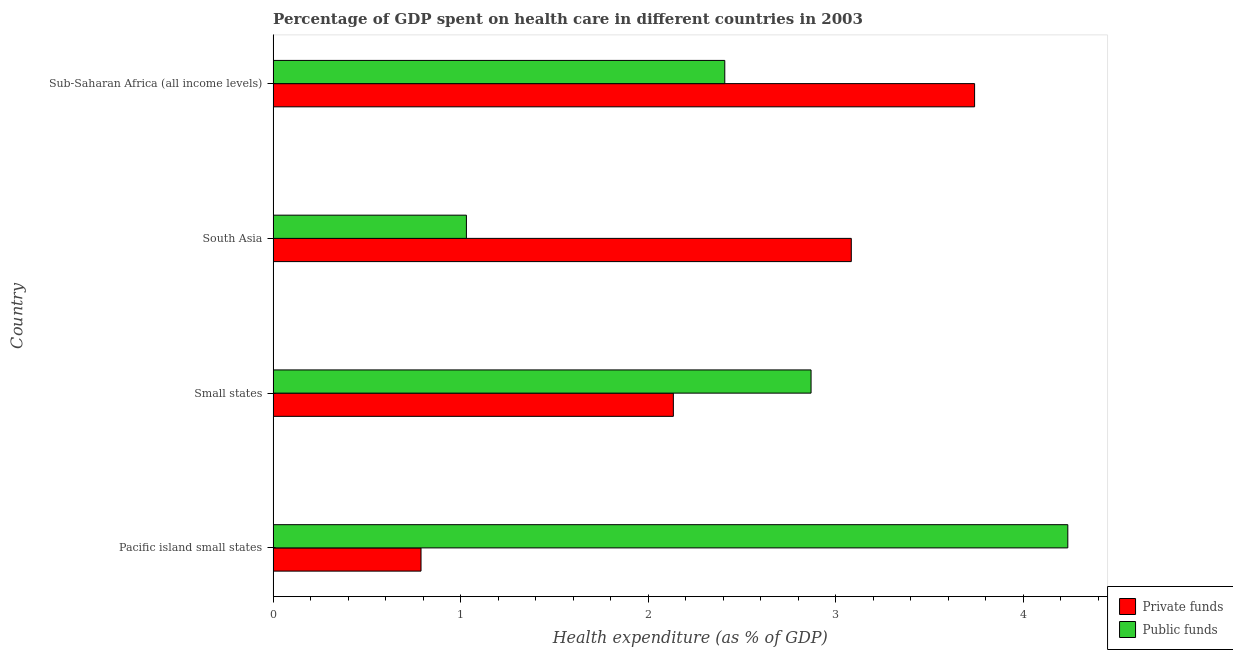How many groups of bars are there?
Offer a very short reply. 4. How many bars are there on the 3rd tick from the top?
Your response must be concise. 2. What is the label of the 1st group of bars from the top?
Your answer should be very brief. Sub-Saharan Africa (all income levels). What is the amount of private funds spent in healthcare in Pacific island small states?
Offer a terse response. 0.79. Across all countries, what is the maximum amount of public funds spent in healthcare?
Your response must be concise. 4.24. Across all countries, what is the minimum amount of private funds spent in healthcare?
Your answer should be very brief. 0.79. In which country was the amount of private funds spent in healthcare maximum?
Provide a succinct answer. Sub-Saharan Africa (all income levels). In which country was the amount of private funds spent in healthcare minimum?
Provide a succinct answer. Pacific island small states. What is the total amount of public funds spent in healthcare in the graph?
Offer a terse response. 10.54. What is the difference between the amount of public funds spent in healthcare in South Asia and that in Sub-Saharan Africa (all income levels)?
Give a very brief answer. -1.38. What is the difference between the amount of public funds spent in healthcare in Pacific island small states and the amount of private funds spent in healthcare in Sub-Saharan Africa (all income levels)?
Offer a terse response. 0.5. What is the average amount of public funds spent in healthcare per country?
Provide a succinct answer. 2.64. What is the difference between the amount of public funds spent in healthcare and amount of private funds spent in healthcare in South Asia?
Provide a short and direct response. -2.05. In how many countries, is the amount of public funds spent in healthcare greater than 2.6 %?
Provide a short and direct response. 2. What is the ratio of the amount of public funds spent in healthcare in Small states to that in South Asia?
Your response must be concise. 2.78. What is the difference between the highest and the second highest amount of private funds spent in healthcare?
Offer a very short reply. 0.66. What is the difference between the highest and the lowest amount of public funds spent in healthcare?
Your response must be concise. 3.21. In how many countries, is the amount of private funds spent in healthcare greater than the average amount of private funds spent in healthcare taken over all countries?
Your answer should be very brief. 2. Is the sum of the amount of private funds spent in healthcare in Pacific island small states and Small states greater than the maximum amount of public funds spent in healthcare across all countries?
Give a very brief answer. No. What does the 1st bar from the top in Small states represents?
Provide a short and direct response. Public funds. What does the 1st bar from the bottom in Sub-Saharan Africa (all income levels) represents?
Make the answer very short. Private funds. How many bars are there?
Ensure brevity in your answer.  8. Are all the bars in the graph horizontal?
Provide a succinct answer. Yes. How many countries are there in the graph?
Keep it short and to the point. 4. What is the difference between two consecutive major ticks on the X-axis?
Your response must be concise. 1. Are the values on the major ticks of X-axis written in scientific E-notation?
Provide a succinct answer. No. Does the graph contain any zero values?
Provide a succinct answer. No. Does the graph contain grids?
Your response must be concise. No. Where does the legend appear in the graph?
Your answer should be very brief. Bottom right. How are the legend labels stacked?
Provide a short and direct response. Vertical. What is the title of the graph?
Your answer should be very brief. Percentage of GDP spent on health care in different countries in 2003. What is the label or title of the X-axis?
Provide a short and direct response. Health expenditure (as % of GDP). What is the label or title of the Y-axis?
Your answer should be compact. Country. What is the Health expenditure (as % of GDP) of Private funds in Pacific island small states?
Ensure brevity in your answer.  0.79. What is the Health expenditure (as % of GDP) of Public funds in Pacific island small states?
Your response must be concise. 4.24. What is the Health expenditure (as % of GDP) in Private funds in Small states?
Your answer should be compact. 2.13. What is the Health expenditure (as % of GDP) in Public funds in Small states?
Offer a very short reply. 2.87. What is the Health expenditure (as % of GDP) of Private funds in South Asia?
Keep it short and to the point. 3.08. What is the Health expenditure (as % of GDP) in Public funds in South Asia?
Offer a very short reply. 1.03. What is the Health expenditure (as % of GDP) of Private funds in Sub-Saharan Africa (all income levels)?
Your response must be concise. 3.74. What is the Health expenditure (as % of GDP) of Public funds in Sub-Saharan Africa (all income levels)?
Offer a terse response. 2.41. Across all countries, what is the maximum Health expenditure (as % of GDP) of Private funds?
Offer a very short reply. 3.74. Across all countries, what is the maximum Health expenditure (as % of GDP) of Public funds?
Offer a terse response. 4.24. Across all countries, what is the minimum Health expenditure (as % of GDP) in Private funds?
Your answer should be compact. 0.79. Across all countries, what is the minimum Health expenditure (as % of GDP) in Public funds?
Give a very brief answer. 1.03. What is the total Health expenditure (as % of GDP) of Private funds in the graph?
Your answer should be very brief. 9.75. What is the total Health expenditure (as % of GDP) in Public funds in the graph?
Your response must be concise. 10.54. What is the difference between the Health expenditure (as % of GDP) of Private funds in Pacific island small states and that in Small states?
Keep it short and to the point. -1.35. What is the difference between the Health expenditure (as % of GDP) in Public funds in Pacific island small states and that in Small states?
Your response must be concise. 1.37. What is the difference between the Health expenditure (as % of GDP) of Private funds in Pacific island small states and that in South Asia?
Your answer should be compact. -2.29. What is the difference between the Health expenditure (as % of GDP) in Public funds in Pacific island small states and that in South Asia?
Make the answer very short. 3.21. What is the difference between the Health expenditure (as % of GDP) in Private funds in Pacific island small states and that in Sub-Saharan Africa (all income levels)?
Provide a succinct answer. -2.95. What is the difference between the Health expenditure (as % of GDP) of Public funds in Pacific island small states and that in Sub-Saharan Africa (all income levels)?
Offer a very short reply. 1.83. What is the difference between the Health expenditure (as % of GDP) in Private funds in Small states and that in South Asia?
Offer a terse response. -0.95. What is the difference between the Health expenditure (as % of GDP) of Public funds in Small states and that in South Asia?
Your answer should be very brief. 1.84. What is the difference between the Health expenditure (as % of GDP) of Private funds in Small states and that in Sub-Saharan Africa (all income levels)?
Give a very brief answer. -1.61. What is the difference between the Health expenditure (as % of GDP) of Public funds in Small states and that in Sub-Saharan Africa (all income levels)?
Offer a terse response. 0.46. What is the difference between the Health expenditure (as % of GDP) in Private funds in South Asia and that in Sub-Saharan Africa (all income levels)?
Make the answer very short. -0.66. What is the difference between the Health expenditure (as % of GDP) of Public funds in South Asia and that in Sub-Saharan Africa (all income levels)?
Keep it short and to the point. -1.38. What is the difference between the Health expenditure (as % of GDP) of Private funds in Pacific island small states and the Health expenditure (as % of GDP) of Public funds in Small states?
Provide a short and direct response. -2.08. What is the difference between the Health expenditure (as % of GDP) in Private funds in Pacific island small states and the Health expenditure (as % of GDP) in Public funds in South Asia?
Your response must be concise. -0.24. What is the difference between the Health expenditure (as % of GDP) in Private funds in Pacific island small states and the Health expenditure (as % of GDP) in Public funds in Sub-Saharan Africa (all income levels)?
Provide a short and direct response. -1.62. What is the difference between the Health expenditure (as % of GDP) of Private funds in Small states and the Health expenditure (as % of GDP) of Public funds in South Asia?
Provide a short and direct response. 1.1. What is the difference between the Health expenditure (as % of GDP) of Private funds in Small states and the Health expenditure (as % of GDP) of Public funds in Sub-Saharan Africa (all income levels)?
Ensure brevity in your answer.  -0.27. What is the difference between the Health expenditure (as % of GDP) in Private funds in South Asia and the Health expenditure (as % of GDP) in Public funds in Sub-Saharan Africa (all income levels)?
Give a very brief answer. 0.67. What is the average Health expenditure (as % of GDP) of Private funds per country?
Your answer should be very brief. 2.44. What is the average Health expenditure (as % of GDP) of Public funds per country?
Ensure brevity in your answer.  2.64. What is the difference between the Health expenditure (as % of GDP) in Private funds and Health expenditure (as % of GDP) in Public funds in Pacific island small states?
Your response must be concise. -3.45. What is the difference between the Health expenditure (as % of GDP) of Private funds and Health expenditure (as % of GDP) of Public funds in Small states?
Your response must be concise. -0.73. What is the difference between the Health expenditure (as % of GDP) in Private funds and Health expenditure (as % of GDP) in Public funds in South Asia?
Provide a short and direct response. 2.05. What is the difference between the Health expenditure (as % of GDP) in Private funds and Health expenditure (as % of GDP) in Public funds in Sub-Saharan Africa (all income levels)?
Provide a succinct answer. 1.33. What is the ratio of the Health expenditure (as % of GDP) of Private funds in Pacific island small states to that in Small states?
Your response must be concise. 0.37. What is the ratio of the Health expenditure (as % of GDP) in Public funds in Pacific island small states to that in Small states?
Provide a succinct answer. 1.48. What is the ratio of the Health expenditure (as % of GDP) of Private funds in Pacific island small states to that in South Asia?
Make the answer very short. 0.26. What is the ratio of the Health expenditure (as % of GDP) of Public funds in Pacific island small states to that in South Asia?
Offer a terse response. 4.11. What is the ratio of the Health expenditure (as % of GDP) of Private funds in Pacific island small states to that in Sub-Saharan Africa (all income levels)?
Keep it short and to the point. 0.21. What is the ratio of the Health expenditure (as % of GDP) in Public funds in Pacific island small states to that in Sub-Saharan Africa (all income levels)?
Provide a succinct answer. 1.76. What is the ratio of the Health expenditure (as % of GDP) of Private funds in Small states to that in South Asia?
Keep it short and to the point. 0.69. What is the ratio of the Health expenditure (as % of GDP) of Public funds in Small states to that in South Asia?
Make the answer very short. 2.78. What is the ratio of the Health expenditure (as % of GDP) in Private funds in Small states to that in Sub-Saharan Africa (all income levels)?
Ensure brevity in your answer.  0.57. What is the ratio of the Health expenditure (as % of GDP) in Public funds in Small states to that in Sub-Saharan Africa (all income levels)?
Offer a terse response. 1.19. What is the ratio of the Health expenditure (as % of GDP) in Private funds in South Asia to that in Sub-Saharan Africa (all income levels)?
Give a very brief answer. 0.82. What is the ratio of the Health expenditure (as % of GDP) in Public funds in South Asia to that in Sub-Saharan Africa (all income levels)?
Your response must be concise. 0.43. What is the difference between the highest and the second highest Health expenditure (as % of GDP) of Private funds?
Give a very brief answer. 0.66. What is the difference between the highest and the second highest Health expenditure (as % of GDP) of Public funds?
Your response must be concise. 1.37. What is the difference between the highest and the lowest Health expenditure (as % of GDP) of Private funds?
Your response must be concise. 2.95. What is the difference between the highest and the lowest Health expenditure (as % of GDP) in Public funds?
Your response must be concise. 3.21. 